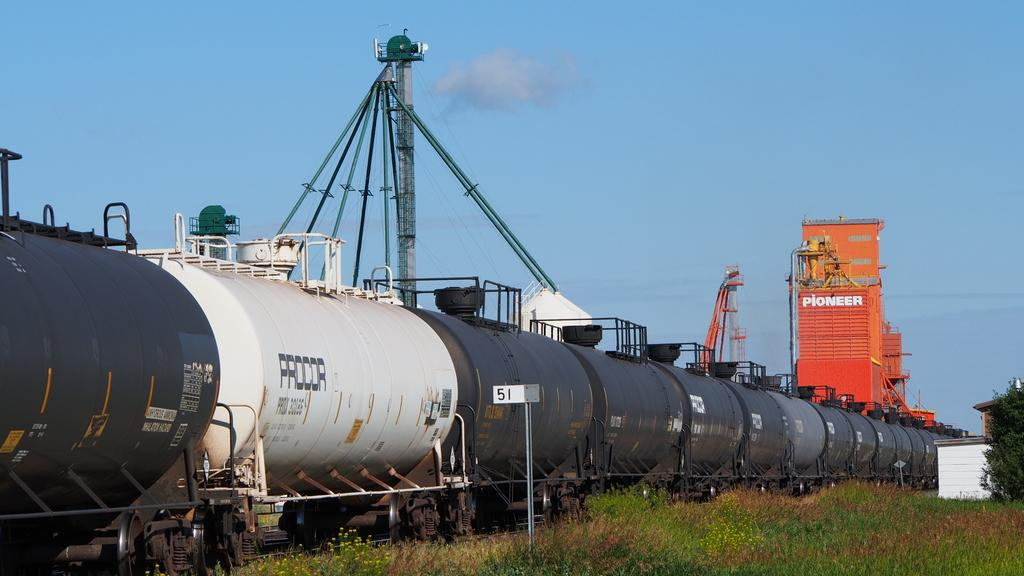What is the main subject in the center of the image? There is a train in the center of the image. What type of terrain is visible at the bottom side of the image? There is grassland at the bottom side of the image. How many babies are crawling on the train in the image? There are no babies present in the image, and they are not crawling on the train. 